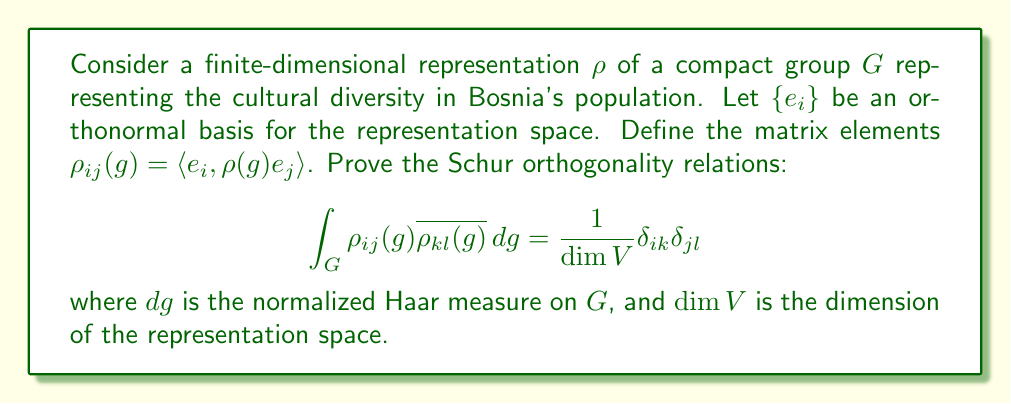Give your solution to this math problem. To prove the Schur orthogonality relations, we'll follow these steps:

1) First, consider the linear map $T: V \to V$ defined by:

   $$T = \int_G \rho(g) \langle v, \rho(g)w \rangle \, dg$$

   where $v$ and $w$ are arbitrary vectors in $V$.

2) We can show that $T$ commutes with all $\rho(h)$ for $h \in G$:

   $$\rho(h)T = T\rho(h)$$

   This is because of the invariance of the Haar measure.

3) By Schur's lemma, since $\rho$ is irreducible, $T$ must be a scalar multiple of the identity:

   $$T = c \cdot I$$

   where $c$ is some constant.

4) To find $c$, we can take the trace of both sides:

   $$\text{Tr}(T) = c \cdot \dim V$$

5) On the other hand, we can compute the trace directly:

   $$\text{Tr}(T) = \sum_i \langle e_i, Te_i \rangle = \int_G \sum_i \langle e_i, \rho(g)e_i \rangle \, dg = \int_G \chi_\rho(g) \, dg = 1$$

   where $\chi_\rho$ is the character of the representation.

6) Therefore, we have:

   $$c = \frac{1}{\dim V}$$

7) Now, we can compute the matrix elements of $T$:

   $$\langle e_k, Te_l \rangle = \int_G \langle e_k, \rho(g)e_i \rangle \langle e_i, \rho(g)e_l \rangle \, dg = \int_G \rho_{ki}(g) \overline{\rho_{il}(g)} \, dg$$

8) But we also know that:

   $$\langle e_k, Te_l \rangle = c \delta_{kl} = \frac{1}{\dim V} \delta_{kl}$$

9) Equating these two expressions gives us the desired result:

   $$\int_G \rho_{ki}(g) \overline{\rho_{il}(g)} \, dg = \frac{1}{\dim V} \delta_{kl}$$

This proves the Schur orthogonality relations for the representation $\rho$ of the group $G$.
Answer: $\int_G \rho_{ij}(g) \overline{\rho_{kl}(g)} \, dg = \frac{1}{\dim V} \delta_{ik} \delta_{jl}$ 